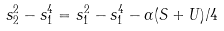<formula> <loc_0><loc_0><loc_500><loc_500>s _ { 2 } ^ { 2 } - s _ { 1 } ^ { 4 } = s _ { 1 } ^ { 2 } - s _ { 1 } ^ { 4 } - \alpha ( S + U ) / 4</formula> 